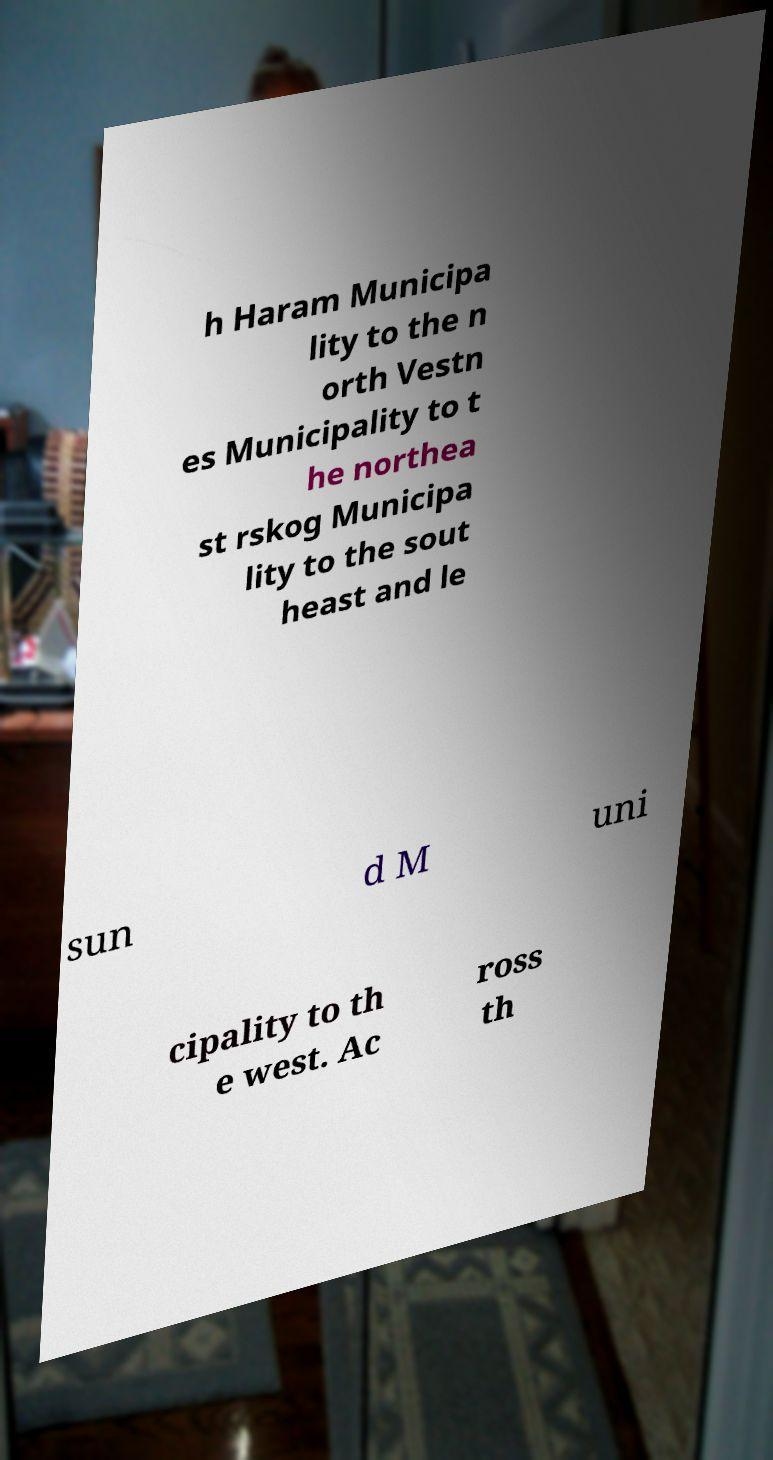Could you extract and type out the text from this image? h Haram Municipa lity to the n orth Vestn es Municipality to t he northea st rskog Municipa lity to the sout heast and le sun d M uni cipality to th e west. Ac ross th 